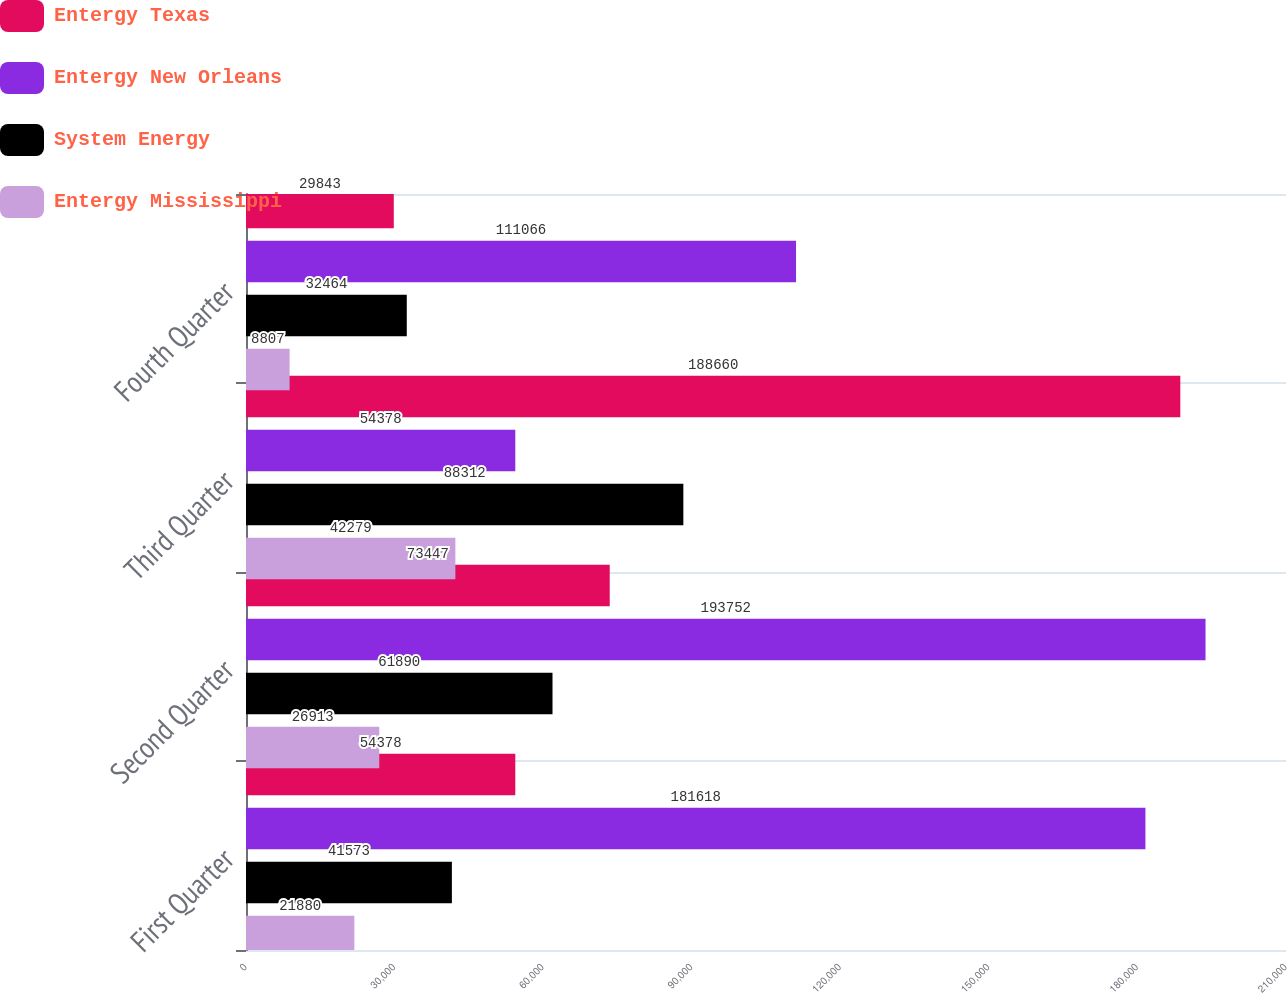Convert chart to OTSL. <chart><loc_0><loc_0><loc_500><loc_500><stacked_bar_chart><ecel><fcel>First Quarter<fcel>Second Quarter<fcel>Third Quarter<fcel>Fourth Quarter<nl><fcel>Entergy Texas<fcel>54378<fcel>73447<fcel>188660<fcel>29843<nl><fcel>Entergy New Orleans<fcel>181618<fcel>193752<fcel>54378<fcel>111066<nl><fcel>System Energy<fcel>41573<fcel>61890<fcel>88312<fcel>32464<nl><fcel>Entergy Mississippi<fcel>21880<fcel>26913<fcel>42279<fcel>8807<nl></chart> 